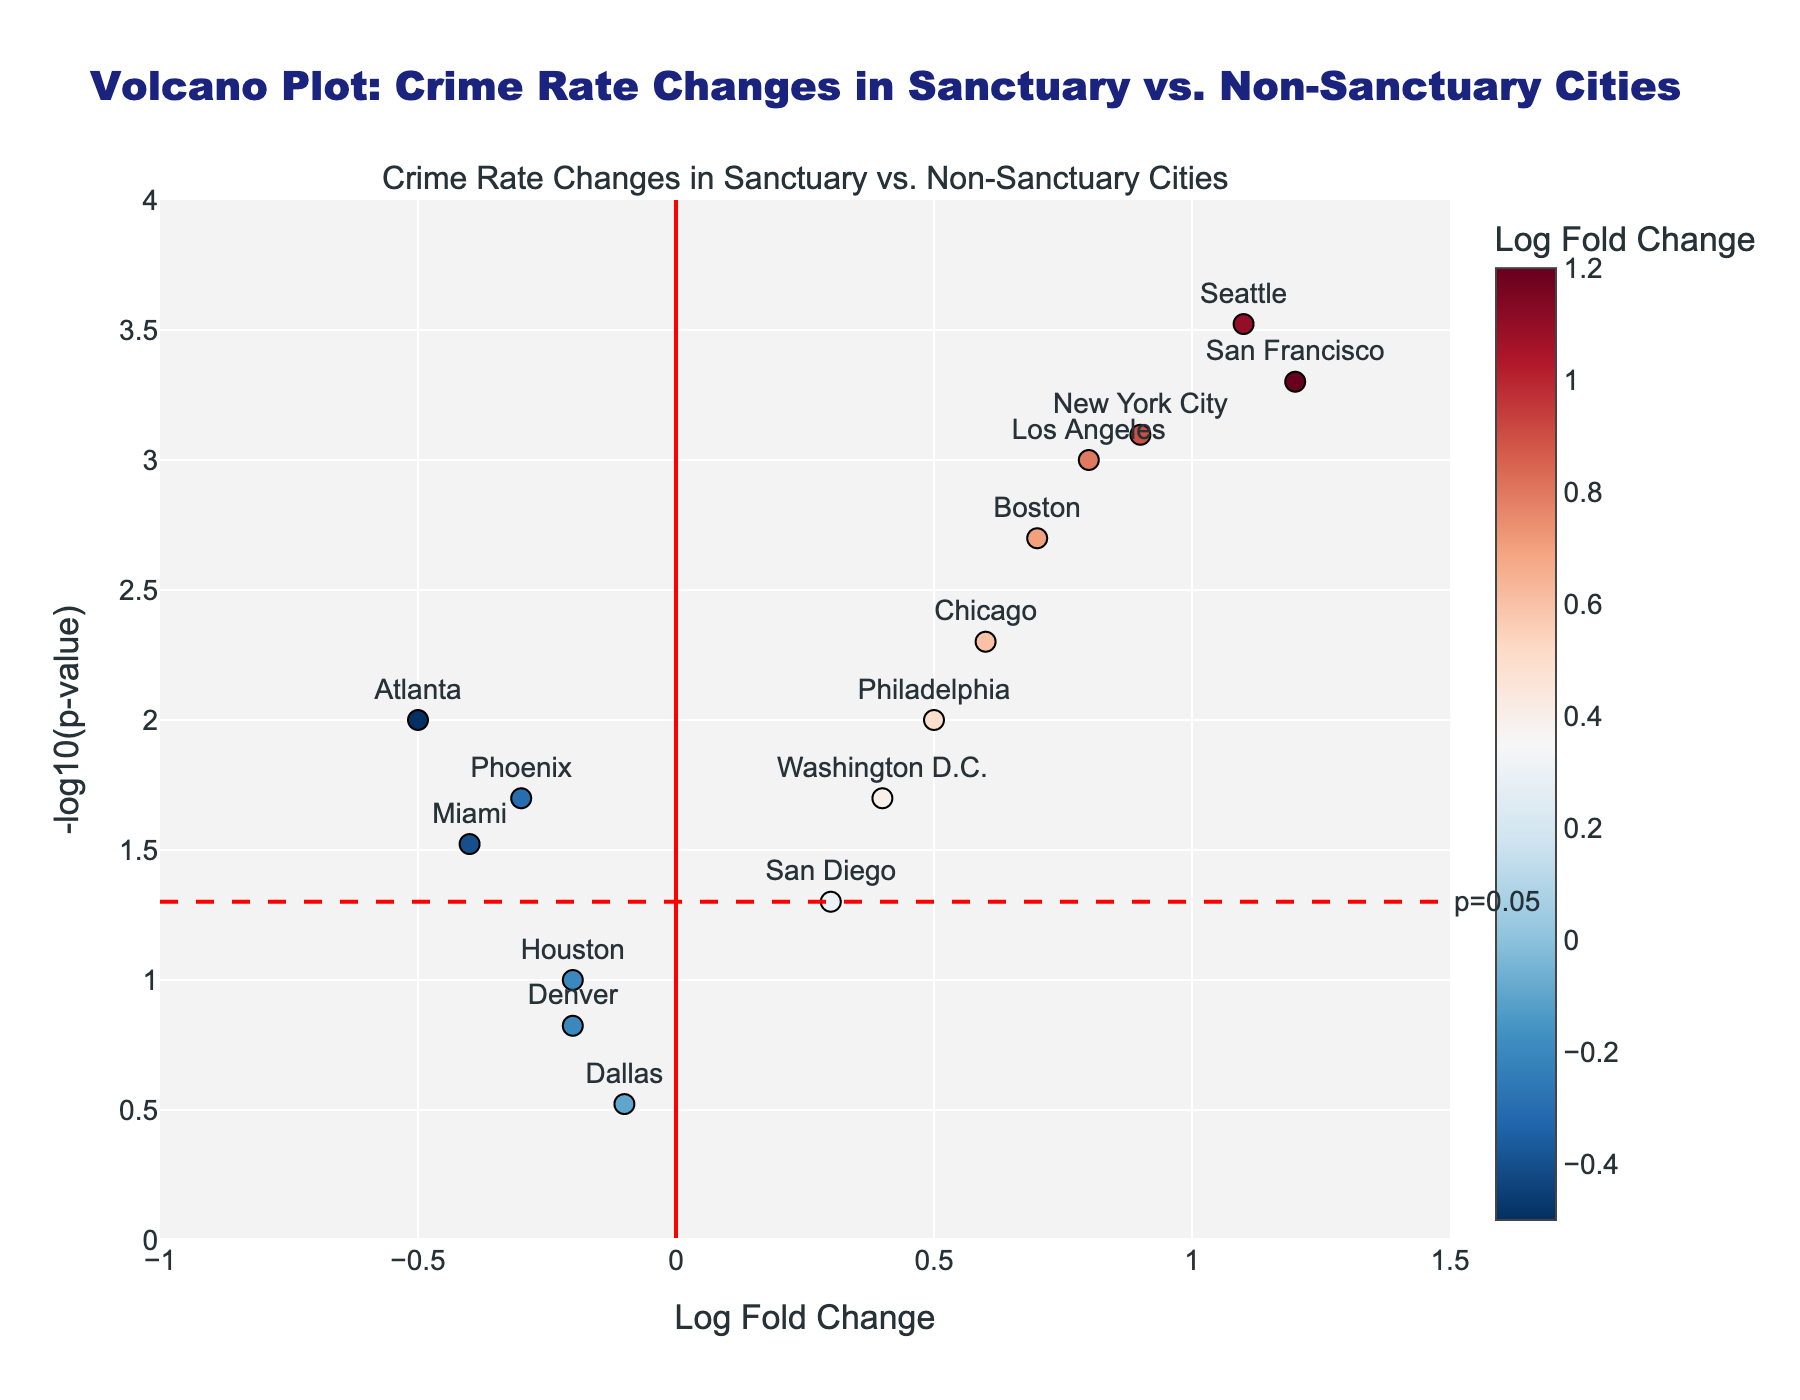How many cities have a Log Fold Change greater than 0.5? By observing the x-axis (Log Fold Change > 0.5), count the cities above this threshold. Los Angeles, San Francisco, Chicago, New York City, Seattle, Boston, Philadelphia, and Washington D.C. are above 0.5.
Answer: 8 Which city has the highest -log10(p-value)? By checking the y-axis values, San Francisco has the highest -log10(p-value), corresponding to the smallest p-value on the plot.
Answer: San Francisco What are the cities with a significant change (p-value < 0.05) and a negative Log Fold Change? Set the p-value threshold at 0.05. Phoenix, Miami, and Atlanta have negative Log Fold Changes and p-values below 0.05.
Answer: Phoenix, Miami, Atlanta Which two cities have the closest Log Fold Change values? Compare the x-axis values. Dallas and Denver have the closest Log Fold Changes since they are both close to -0.1 and -0.2, respectively.
Answer: Dallas and Denver What is the Log Fold Change and -log10(p-value) of Seattle? Locate Seattle on the plot, then read the corresponding x and y values. Log Fold Change is 1.1, -log10(p-value) is about 3.52.
Answer: Log Fold Change: 1.1, -log10(p-value): 3.52 Which city shows the largest positive change in crime rate? Identify the highest Log Fold Change on the x-axis, corresponding to San Francisco.
Answer: San Francisco How many cities have a p-value considered insignificant (p-value > 0.05)? By observing points below the y-axis reference line (y = -log10(0.05)), Dallas, Houston, Denver, and San Diego fall in this category.
Answer: 4 Compare the Log Fold Change between Los Angeles and New York City. Which one is higher? Use x-axis values: Los Angeles has a Log Fold Change of 0.8, while New York City has 0.9. Therefore, New York City's is higher.
Answer: New York City Which city has the smallest positive -log10(p-value)? The city with the lowest y-axis value, but greater than zero, is Philadelphia with a y value of about 2.
Answer: Philadelphia 